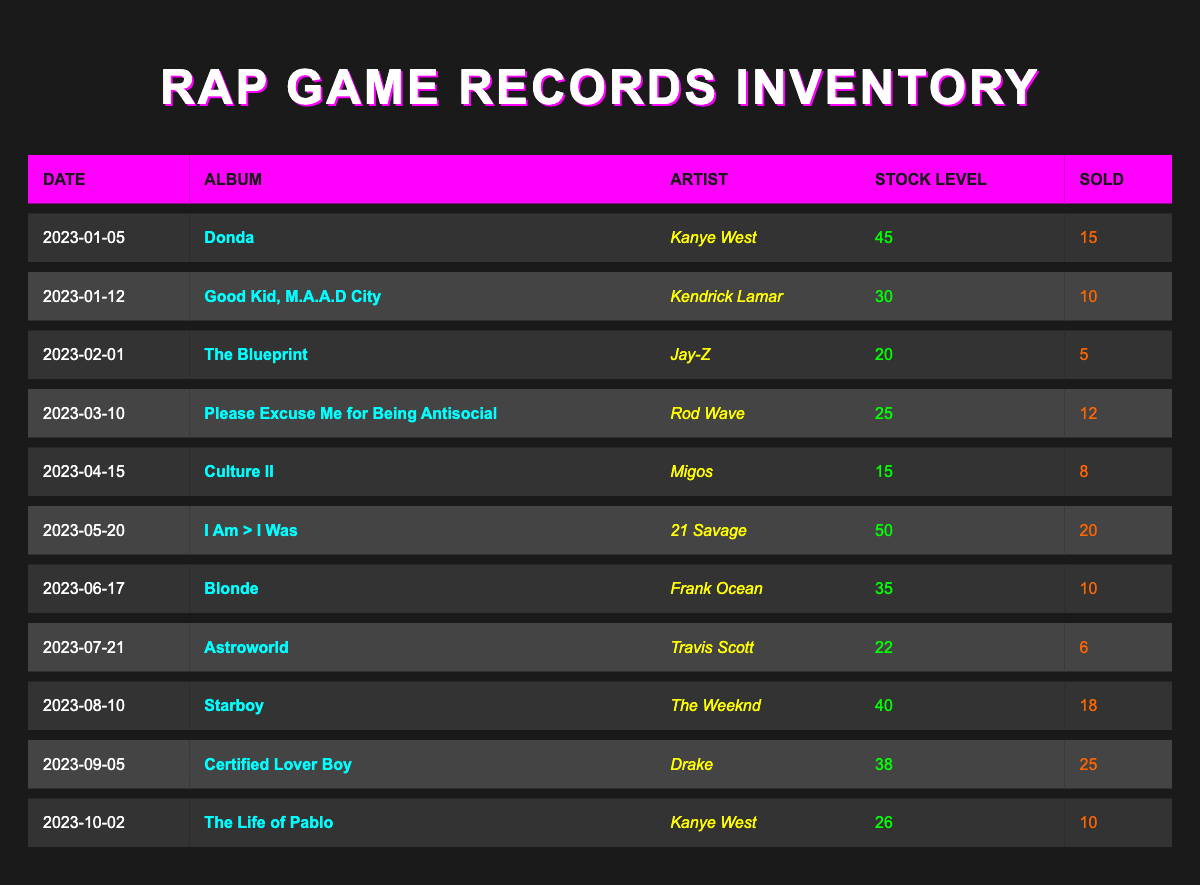What is the stock level of "Donda" by Kanye West? The table shows that on 2023-01-05, the stock level for "Donda" is listed as 45.
Answer: 45 How many copies of "Culture II" by Migos were sold? According to the table, "Culture II" has a sold count of 8 on 2023-04-15.
Answer: 8 What was the average stock level of all albums listed in the inventory? To find the average, we sum the stock levels: (45 + 30 + 20 + 25 + 15 + 50 + 35 + 22 + 40 + 38 + 26) =  406. There are 11 albums, so the average is 406 / 11 = 36. \
Answer: 36 Did "Certified Lover Boy" sell more than "I Am > I Was"? "Certified Lover Boy" sold 25 copies, while "I Am > I Was" sold 20 copies. Since 25 is greater than 20, the statement is true.
Answer: Yes In which month did "Blonde" by Frank Ocean have the highest stock level, and what was it? Looking at the table, "Blonde" has a stock of 35 on 2023-06-17. This is the highest stock level among the albums in the inventory, as no other album has a higher stock in the records.
Answer: June, 35 What is the total number of records sold for albums by Kanye West? Kanye West has two albums in the table: "Donda" sold 15 copies and "The Life of Pablo" sold 10 copies. Adding these gives: 15 + 10 = 25, which is the total.
Answer: 25 Which album had the lowest stock level in the inventory? The lowest stock level in the table is 15, associated with "Culture II" by Migos on 2023-04-15.
Answer: Culture II How many albums had a stock level greater than 35? The albums with stock levels greater than 35 are "Donda" (45), "I Am > I Was" (50), and "Starboy" (40). So that makes a total of 3 albums.
Answer: 3 Which artist had the most albums listed in the inventory? The table lists two albums for Kanye West: "Donda" and "The Life of Pablo." No other artist has more than one album in this particular record, making Kanye West the artist with the most albums listed.
Answer: Kanye West 